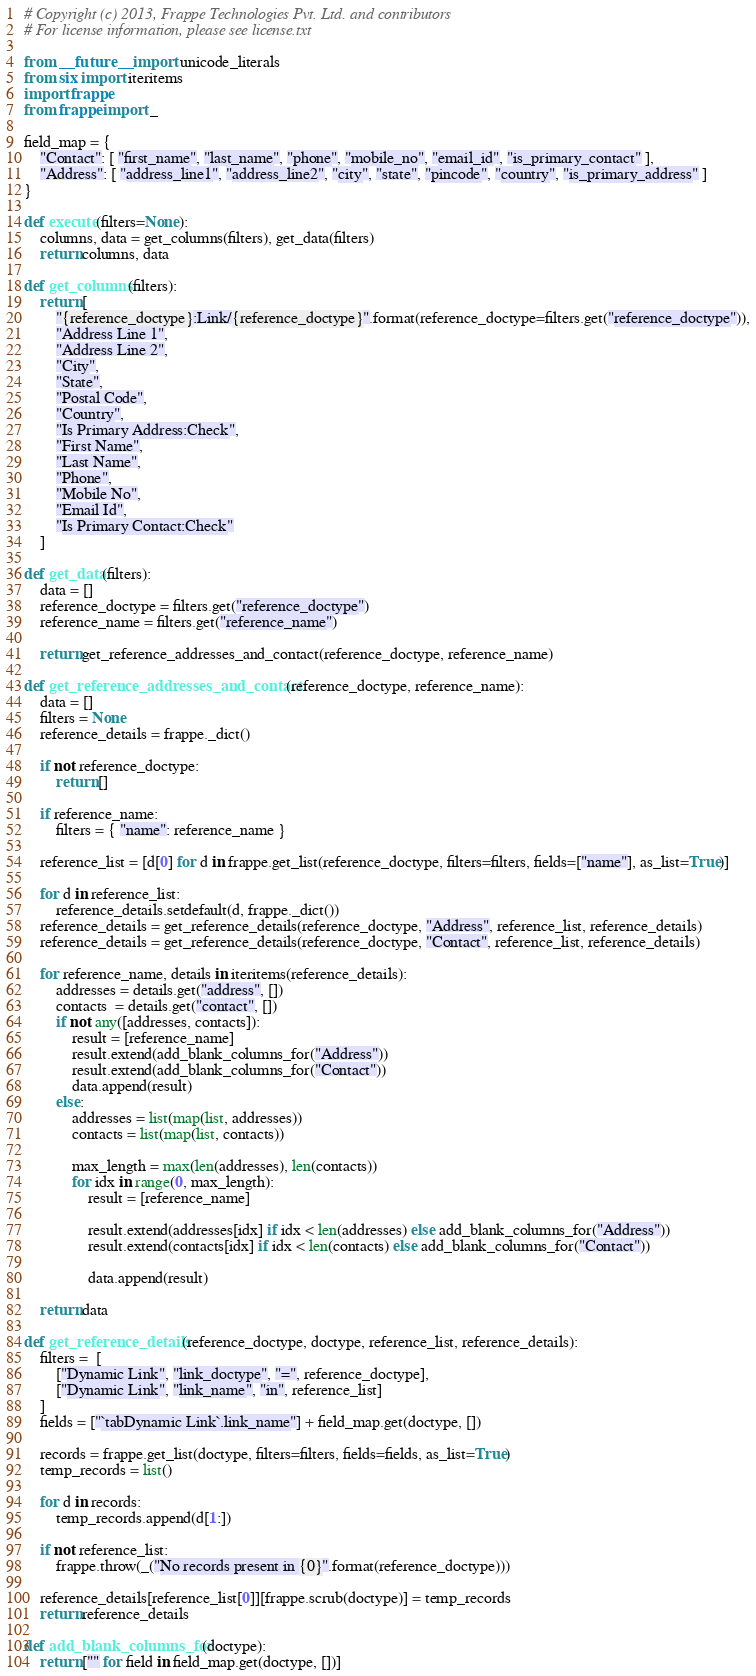<code> <loc_0><loc_0><loc_500><loc_500><_Python_># Copyright (c) 2013, Frappe Technologies Pvt. Ltd. and contributors
# For license information, please see license.txt

from __future__ import unicode_literals
from six import iteritems
import frappe
from frappe import _

field_map = {
	"Contact": [ "first_name", "last_name", "phone", "mobile_no", "email_id", "is_primary_contact" ],
	"Address": [ "address_line1", "address_line2", "city", "state", "pincode", "country", "is_primary_address" ]
}

def execute(filters=None):
	columns, data = get_columns(filters), get_data(filters)
	return columns, data

def get_columns(filters):
	return [
		"{reference_doctype}:Link/{reference_doctype}".format(reference_doctype=filters.get("reference_doctype")),
		"Address Line 1",
		"Address Line 2",
		"City",
		"State",
		"Postal Code",
		"Country",
		"Is Primary Address:Check",
		"First Name",
		"Last Name",
		"Phone",
		"Mobile No",
		"Email Id",
		"Is Primary Contact:Check"
	]

def get_data(filters):
	data = []
	reference_doctype = filters.get("reference_doctype")
	reference_name = filters.get("reference_name")

	return get_reference_addresses_and_contact(reference_doctype, reference_name)

def get_reference_addresses_and_contact(reference_doctype, reference_name):
	data = []
	filters = None
	reference_details = frappe._dict()

	if not reference_doctype:
		return []

	if reference_name:
		filters = { "name": reference_name }

	reference_list = [d[0] for d in frappe.get_list(reference_doctype, filters=filters, fields=["name"], as_list=True)]

	for d in reference_list:
		reference_details.setdefault(d, frappe._dict())
	reference_details = get_reference_details(reference_doctype, "Address", reference_list, reference_details)
	reference_details = get_reference_details(reference_doctype, "Contact", reference_list, reference_details)

	for reference_name, details in iteritems(reference_details):
		addresses = details.get("address", [])
		contacts  = details.get("contact", [])
		if not any([addresses, contacts]):
			result = [reference_name]
			result.extend(add_blank_columns_for("Address"))
			result.extend(add_blank_columns_for("Contact"))
			data.append(result)
		else:
			addresses = list(map(list, addresses))
			contacts = list(map(list, contacts))

			max_length = max(len(addresses), len(contacts))
			for idx in range(0, max_length):
				result = [reference_name]

				result.extend(addresses[idx] if idx < len(addresses) else add_blank_columns_for("Address"))
				result.extend(contacts[idx] if idx < len(contacts) else add_blank_columns_for("Contact"))

				data.append(result)

	return data

def get_reference_details(reference_doctype, doctype, reference_list, reference_details):
	filters =  [
		["Dynamic Link", "link_doctype", "=", reference_doctype],
		["Dynamic Link", "link_name", "in", reference_list]
	]
	fields = ["`tabDynamic Link`.link_name"] + field_map.get(doctype, [])

	records = frappe.get_list(doctype, filters=filters, fields=fields, as_list=True)
	temp_records = list()

	for d in records:
		temp_records.append(d[1:])

	if not reference_list:
		frappe.throw(_("No records present in {0}".format(reference_doctype)))

	reference_details[reference_list[0]][frappe.scrub(doctype)] = temp_records
	return reference_details

def add_blank_columns_for(doctype):
	return ["" for field in field_map.get(doctype, [])]
</code> 